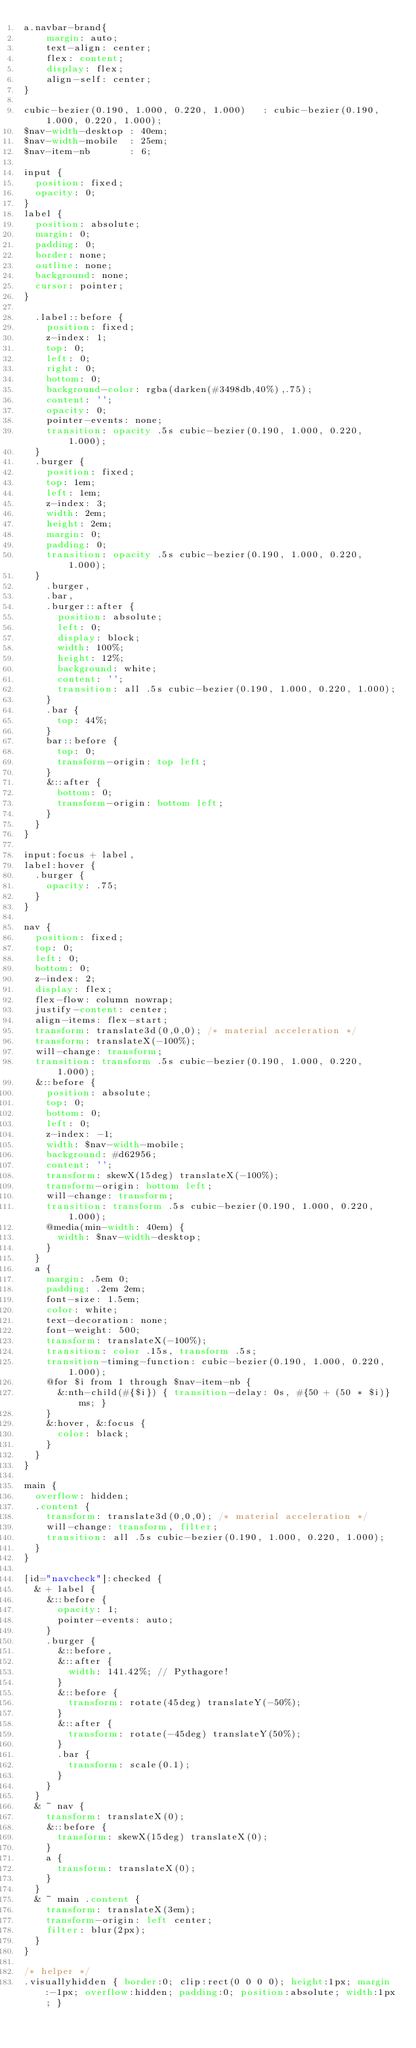<code> <loc_0><loc_0><loc_500><loc_500><_CSS_>a.navbar-brand{
    margin: auto;
    text-align: center;
    flex: content;
    display: flex;
    align-self: center;
}

cubic-bezier(0.190, 1.000, 0.220, 1.000)   : cubic-bezier(0.190, 1.000, 0.220, 1.000);
$nav-width-desktop : 40em;
$nav-width-mobile  : 25em;
$nav-item-nb       : 6;

input {
	position: fixed;
	opacity: 0;
}
label {
	position: absolute;
	margin: 0;
	padding: 0;
	border: none;
	outline: none;
	background: none;
  cursor: pointer;
}
  
	.label::before {
		position: fixed;
		z-index: 1;
		top: 0;
		left: 0;
		right: 0;
		bottom: 0;
		background-color: rgba(darken(#3498db,40%),.75);
		content: '';
		opacity: 0;
		pointer-events: none;
		transition: opacity .5s cubic-bezier(0.190, 1.000, 0.220, 1.000);
	}
	.burger {
		position: fixed;
		top: 1em;
		left: 1em;
		z-index: 3;
		width: 2em;
		height: 2em;
		margin: 0;
		padding: 0;
    transition: opacity .5s cubic-bezier(0.190, 1.000, 0.220, 1.000);
  }
		.burger,
		.bar,
		.burger::after {
			position: absolute;
			left: 0;
			display: block;
			width: 100%;
			height: 12%;
			background: white;
			content: '';
			transition: all .5s cubic-bezier(0.190, 1.000, 0.220, 1.000);
		}
		.bar {
			top: 44%;
		}
		bar::before {
			top: 0;
			transform-origin: top left;
		}
		&::after {
			bottom: 0;
			transform-origin: bottom left;
		}
	}
}

input:focus + label,
label:hover {
	.burger {
		opacity: .75;
	}
}

nav {
	position: fixed;
	top: 0;
	left: 0;
	bottom: 0;
	z-index: 2;
	display: flex;
	flex-flow: column nowrap;
	justify-content: center;
	align-items: flex-start;
	transform: translate3d(0,0,0); /* material acceleration */
	transform: translateX(-100%);
	will-change: transform;
	transition: transform .5s cubic-bezier(0.190, 1.000, 0.220, 1.000);
	&::before {
		position: absolute;
		top: 0;
		bottom: 0;
		left: 0; 
		z-index: -1;
		width: $nav-width-mobile;
		background: #d62956;
		content: '';
		transform: skewX(15deg) translateX(-100%);
		transform-origin: bottom left;
		will-change: transform;
		transition: transform .5s cubic-bezier(0.190, 1.000, 0.220, 1.000);
		@media(min-width: 40em) {
			width: $nav-width-desktop;
		}
	}
	a {
		margin: .5em 0;
		padding: .2em 2em;
		font-size: 1.5em;
		color: white;
		text-decoration: none;
		font-weight: 500;
		transform: translateX(-100%);
		transition: color .15s, transform .5s;
		transition-timing-function: cubic-bezier(0.190, 1.000, 0.220, 1.000);
		@for $i from 1 through $nav-item-nb {
			&:nth-child(#{$i}) { transition-delay: 0s, #{50 + (50 * $i)}ms; }	
		}
		&:hover, &:focus {
			color: black;
		}
	}
}

main {
	overflow: hidden;
	.content {
		transform: translate3d(0,0,0); /* material acceleration */
		will-change: transform, filter;
		transition: all .5s cubic-bezier(0.190, 1.000, 0.220, 1.000);
	}
}

[id="navcheck"]:checked {
	& + label {
		&::before {
			opacity: 1;
			pointer-events: auto;
		}
		.burger {
			&::before,
			&::after {
				width: 141.42%; // Pythagore!
			}
			&::before {
				transform: rotate(45deg) translateY(-50%);
			}
			&::after {
				transform: rotate(-45deg) translateY(50%);
			}
			.bar {
				transform: scale(0.1);
			}
		}
	}
	& ~ nav {
		transform: translateX(0);
		&::before {
			transform: skewX(15deg) translateX(0);
		}
		a {
			transform: translateX(0);
		}
	}
	& ~ main .content {
		transform: translateX(3em);
		transform-origin: left center;
		filter: blur(2px);
	}
}

/* helper */
.visuallyhidden { border:0; clip:rect(0 0 0 0);	height:1px; margin:-1px; overflow:hidden; padding:0; position:absolute; width:1px; }</code> 